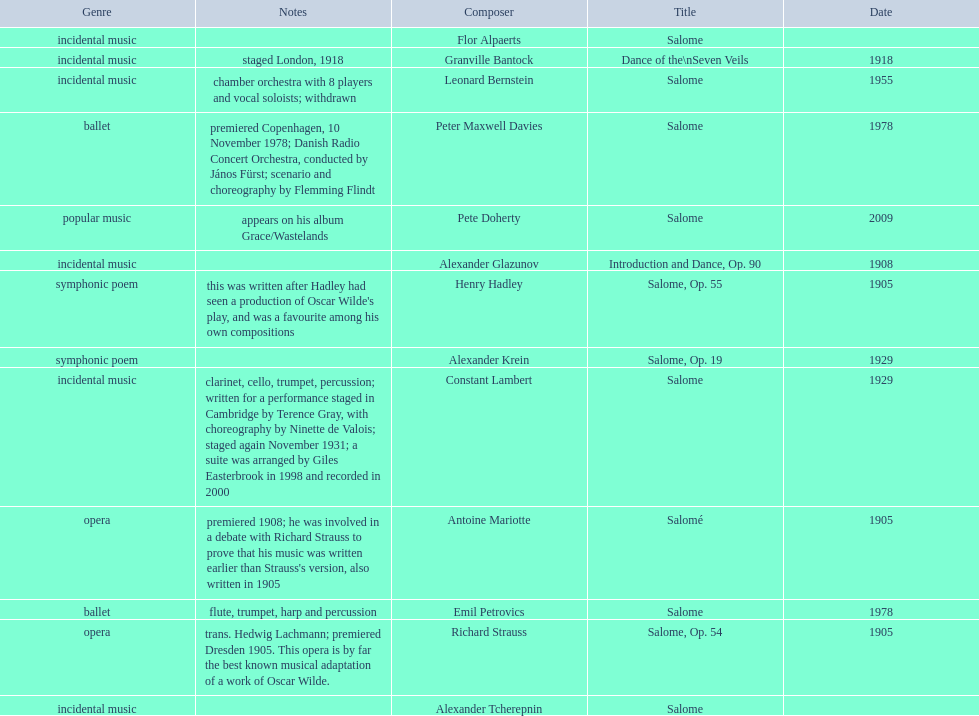Would you be able to parse every entry in this table? {'header': ['Genre', 'Notes', 'Composer', 'Title', 'Date'], 'rows': [['incidental\xa0music', '', 'Flor Alpaerts', 'Salome', ''], ['incidental music', 'staged London, 1918', 'Granville Bantock', 'Dance of the\\nSeven Veils', '1918'], ['incidental music', 'chamber orchestra with 8 players and vocal soloists; withdrawn', 'Leonard Bernstein', 'Salome', '1955'], ['ballet', 'premiered Copenhagen, 10 November 1978; Danish Radio Concert Orchestra, conducted by János Fürst; scenario and choreography by Flemming Flindt', 'Peter\xa0Maxwell\xa0Davies', 'Salome', '1978'], ['popular music', 'appears on his album Grace/Wastelands', 'Pete Doherty', 'Salome', '2009'], ['incidental music', '', 'Alexander Glazunov', 'Introduction and Dance, Op. 90', '1908'], ['symphonic poem', "this was written after Hadley had seen a production of Oscar Wilde's play, and was a favourite among his own compositions", 'Henry Hadley', 'Salome, Op. 55', '1905'], ['symphonic poem', '', 'Alexander Krein', 'Salome, Op. 19', '1929'], ['incidental music', 'clarinet, cello, trumpet, percussion; written for a performance staged in Cambridge by Terence Gray, with choreography by Ninette de Valois; staged again November 1931; a suite was arranged by Giles Easterbrook in 1998 and recorded in 2000', 'Constant Lambert', 'Salome', '1929'], ['opera', "premiered 1908; he was involved in a debate with Richard Strauss to prove that his music was written earlier than Strauss's version, also written in 1905", 'Antoine Mariotte', 'Salomé', '1905'], ['ballet', 'flute, trumpet, harp and percussion', 'Emil Petrovics', 'Salome', '1978'], ['opera', 'trans. Hedwig Lachmann; premiered Dresden 1905. This opera is by far the best known musical adaptation of a work of Oscar Wilde.', 'Richard Strauss', 'Salome, Op. 54', '1905'], ['incidental music', '', 'Alexander\xa0Tcherepnin', 'Salome', '']]} Who is on top of the list? Flor Alpaerts. 